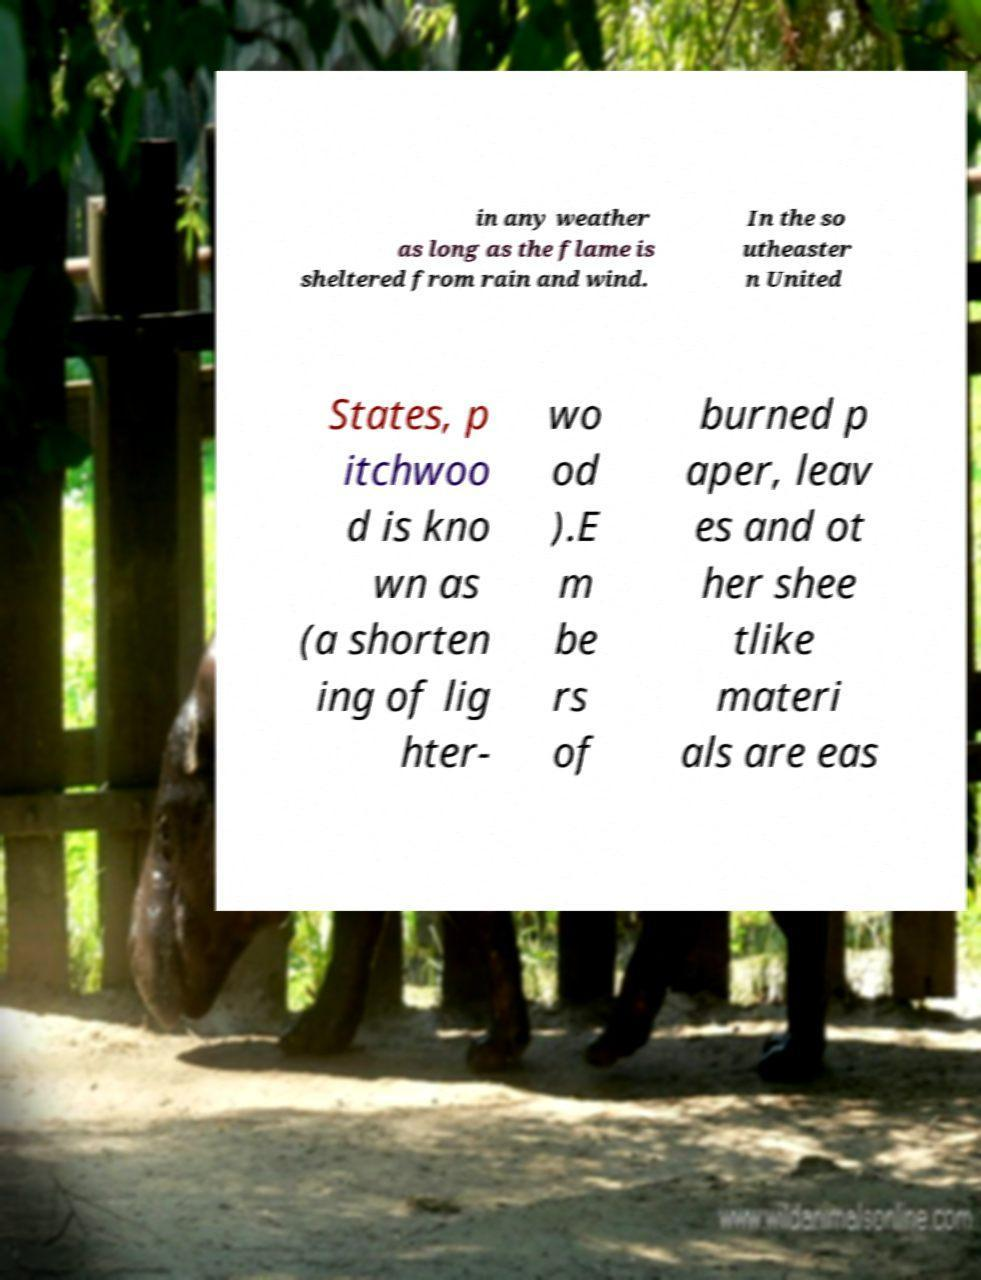For documentation purposes, I need the text within this image transcribed. Could you provide that? in any weather as long as the flame is sheltered from rain and wind. In the so utheaster n United States, p itchwoo d is kno wn as (a shorten ing of lig hter- wo od ).E m be rs of burned p aper, leav es and ot her shee tlike materi als are eas 